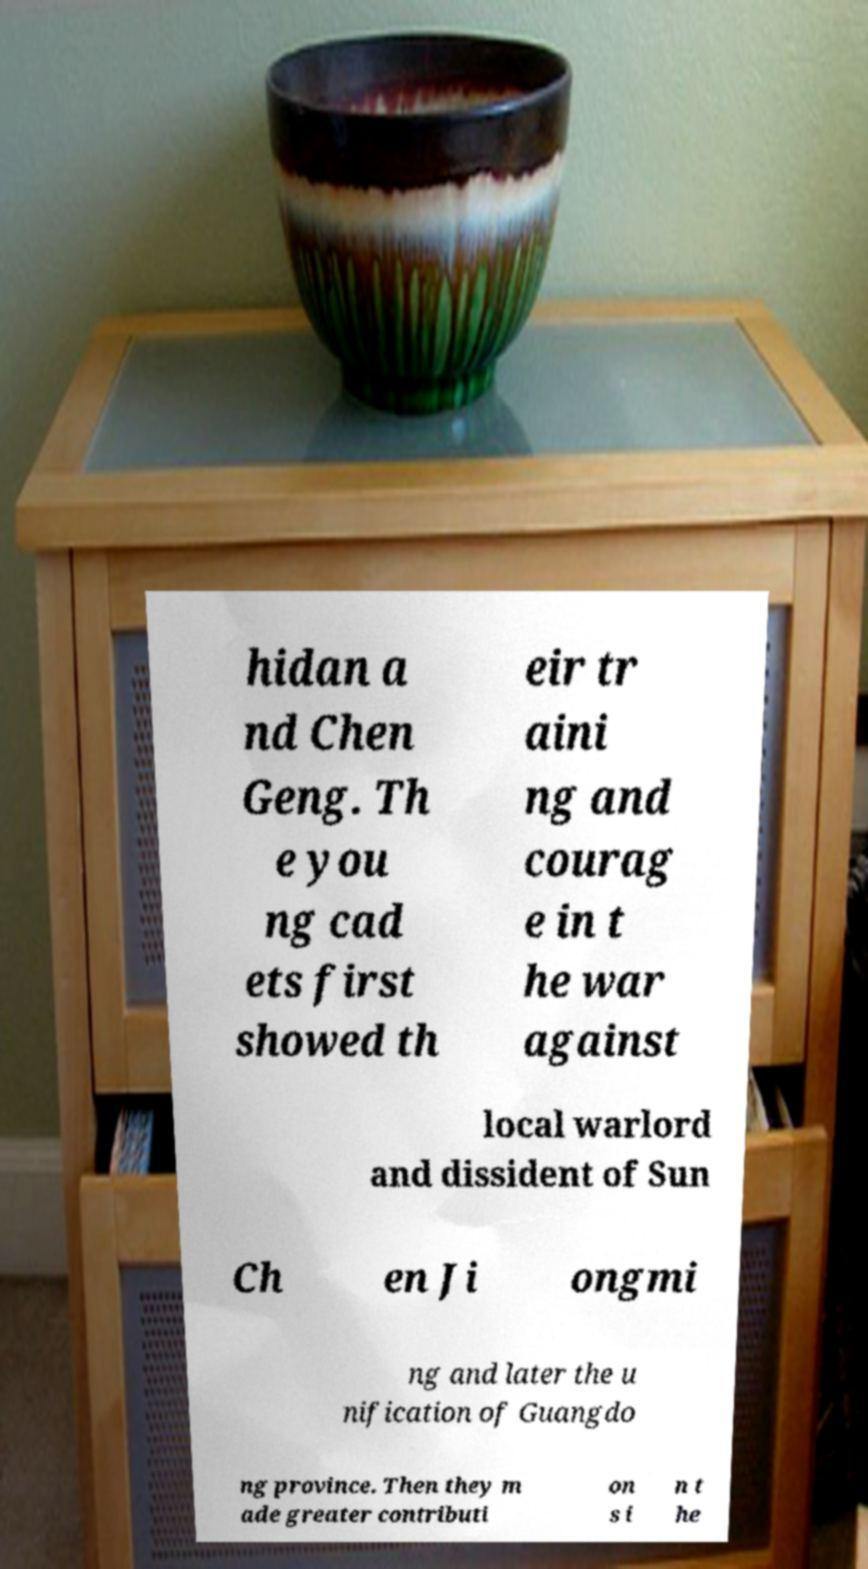What messages or text are displayed in this image? I need them in a readable, typed format. hidan a nd Chen Geng. Th e you ng cad ets first showed th eir tr aini ng and courag e in t he war against local warlord and dissident of Sun Ch en Ji ongmi ng and later the u nification of Guangdo ng province. Then they m ade greater contributi on s i n t he 